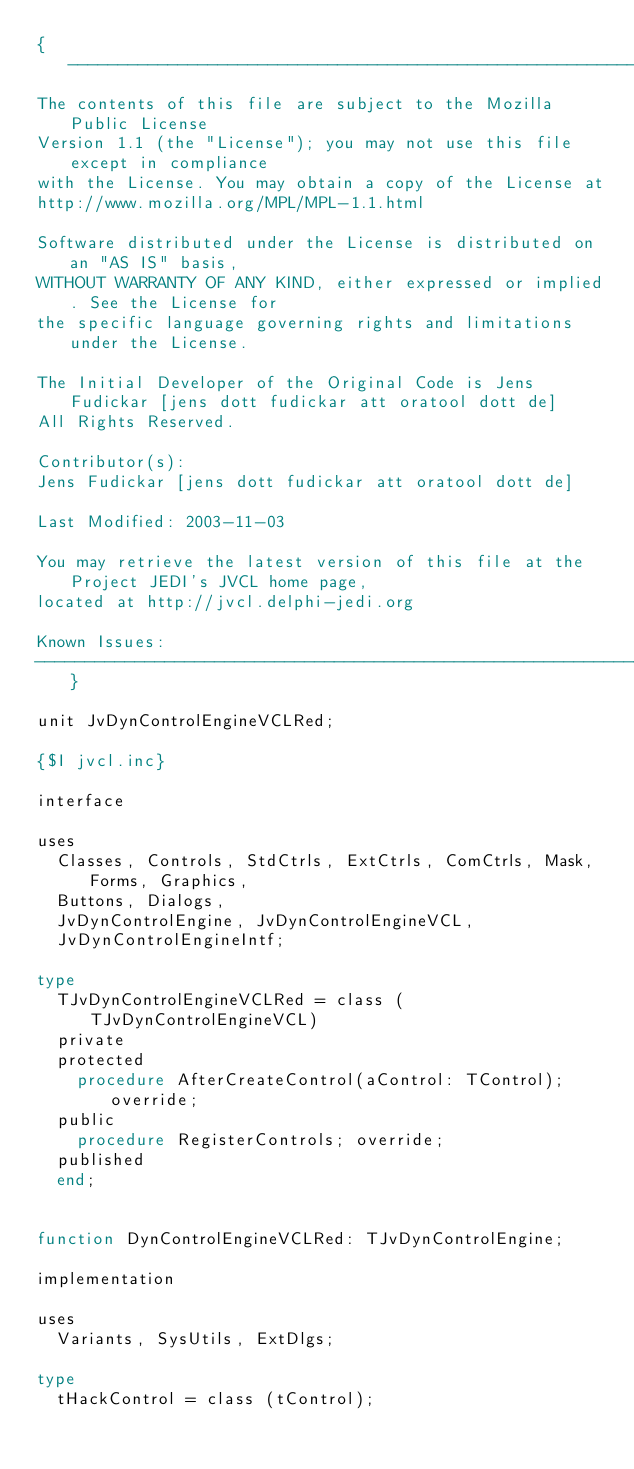Convert code to text. <code><loc_0><loc_0><loc_500><loc_500><_Pascal_>{-----------------------------------------------------------------------------
The contents of this file are subject to the Mozilla Public License
Version 1.1 (the "License"); you may not use this file except in compliance
with the License. You may obtain a copy of the License at
http://www.mozilla.org/MPL/MPL-1.1.html

Software distributed under the License is distributed on an "AS IS" basis,
WITHOUT WARRANTY OF ANY KIND, either expressed or implied. See the License for
the specific language governing rights and limitations under the License.

The Initial Developer of the Original Code is Jens Fudickar [jens dott fudickar att oratool dott de]
All Rights Reserved.

Contributor(s):
Jens Fudickar [jens dott fudickar att oratool dott de]

Last Modified: 2003-11-03

You may retrieve the latest version of this file at the Project JEDI's JVCL home page,
located at http://jvcl.delphi-jedi.org

Known Issues:
-----------------------------------------------------------------------------}

unit JvDynControlEngineVCLRed;

{$I jvcl.inc}

interface

uses
  Classes, Controls, StdCtrls, ExtCtrls, ComCtrls, Mask, Forms, Graphics,
  Buttons, Dialogs,
  JvDynControlEngine, JvDynControlEngineVCL,
  JvDynControlEngineIntf;

type
  TJvDynControlEngineVCLRed = class (TJvDynControlEngineVCL)
  private
  protected
    procedure AfterCreateControl(aControl: TControl); override;
  public
    procedure RegisterControls; override;
  published
  end;


function DynControlEngineVCLRed: TJvDynControlEngine;

implementation

uses
  Variants, SysUtils, ExtDlgs;

type
  tHackControl = class (tControl);
</code> 